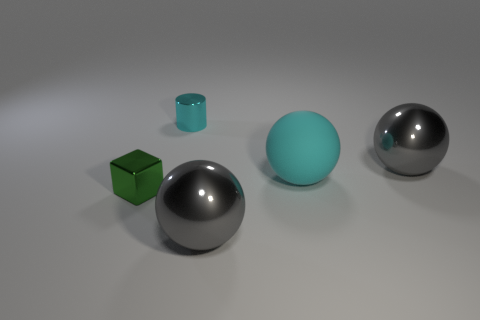Add 2 rubber spheres. How many objects exist? 7 Subtract all balls. How many objects are left? 2 Subtract all large matte spheres. Subtract all small shiny things. How many objects are left? 2 Add 4 large gray metallic things. How many large gray metallic things are left? 6 Add 4 gray metallic spheres. How many gray metallic spheres exist? 6 Subtract 0 red cylinders. How many objects are left? 5 